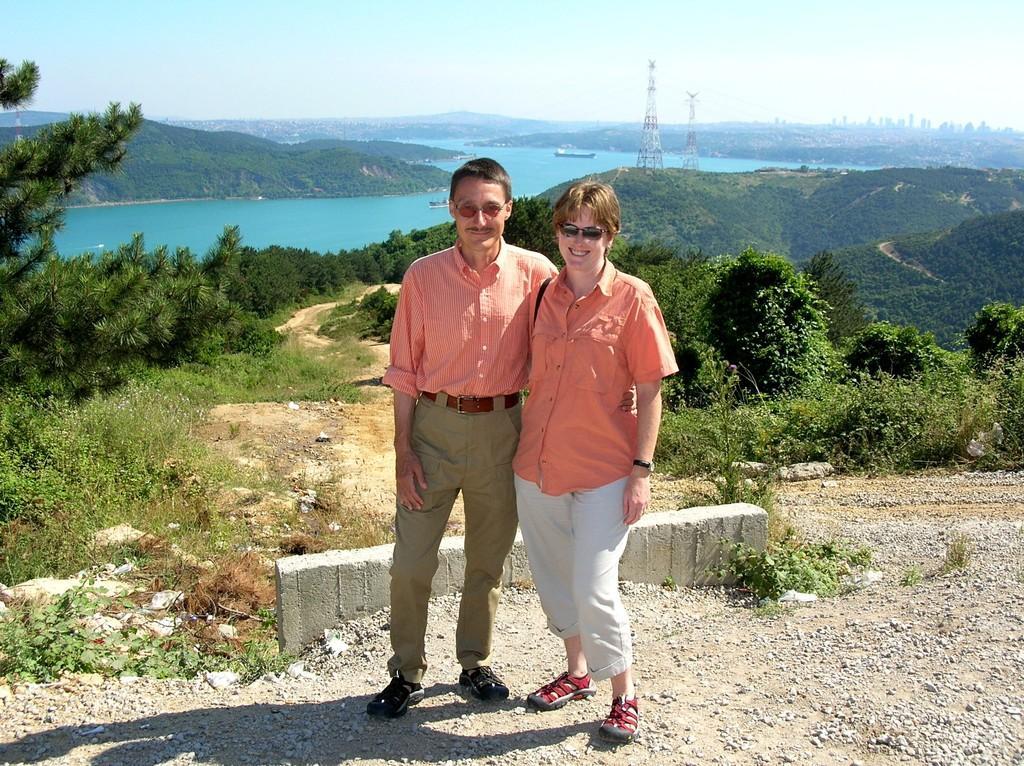Could you give a brief overview of what you see in this image? In the image we can see a woman and a man standing, they are wearing clothes, spectacles and sandal. These are the stones, grass, trees, water, mountain, boat in the water and a sky. There are electric poles. 